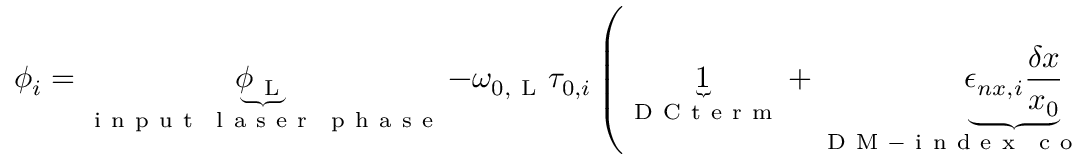<formula> <loc_0><loc_0><loc_500><loc_500>\phi _ { i } = \underbrace { \phi _ { L } } _ { \substack { i n p u t \, l a s e r \, p h a s e } } - \omega _ { 0 , L } \tau _ { 0 , i } \left ( \underbrace { 1 } _ { D C t e r m } + \underbrace { \epsilon _ { n x , i } \frac { \delta x } { x _ { 0 } } } _ { \substack { D M - i n d e x \, c o u p l i n g } } + \underbrace { \epsilon _ { n \omega _ { L } , i } \frac { \delta \omega _ { L } } { \omega _ { 0 , L } } } _ { \substack { o p t i c a l \, d i s p e r s i o n } } + \underbrace { \epsilon _ { L x , i } \frac { \delta x } { x _ { 0 } } } _ { \substack { D M - l e n g t h \, c o u p l i n g } } + \underbrace { \left ( 1 + \epsilon _ { n L , i } \right ) h _ { i } ^ { a c o u s t i c } } _ { \substack { m e c h a n i c a l \, v i b r a t i o n s } } + \underbrace { \frac { \delta \omega _ { L } } { \omega _ { 0 , L } } } _ { \substack { l a s e r f r e q u e n c y \, f l u c t u a t i o n s } } \right ) + \underbrace { \delta \phi _ { i } ^ { t h e r m a l } } _ { \substack { f i b e r t h e r m a l \, f l u c t u a t i o n s } }</formula> 